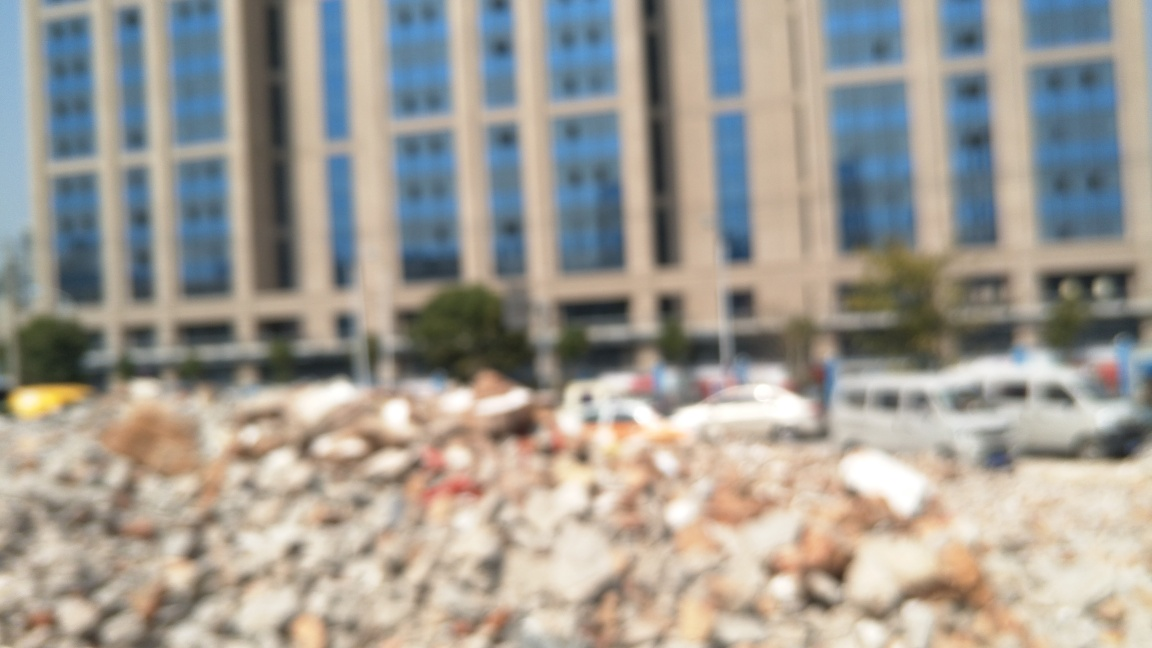Can you describe the main focus of this image and what it might represent? The main focus of the image is a juxtaposition between demolition debris in the foreground and intact buildings in the background. This contrast could represent themes such as urban renewal, the transience of man-made structures, or perhaps the aftermath of a recent event that led to the destruction. Given that the image is blurred intentionally, it could also evoke a sense of memory, change, or loss. 